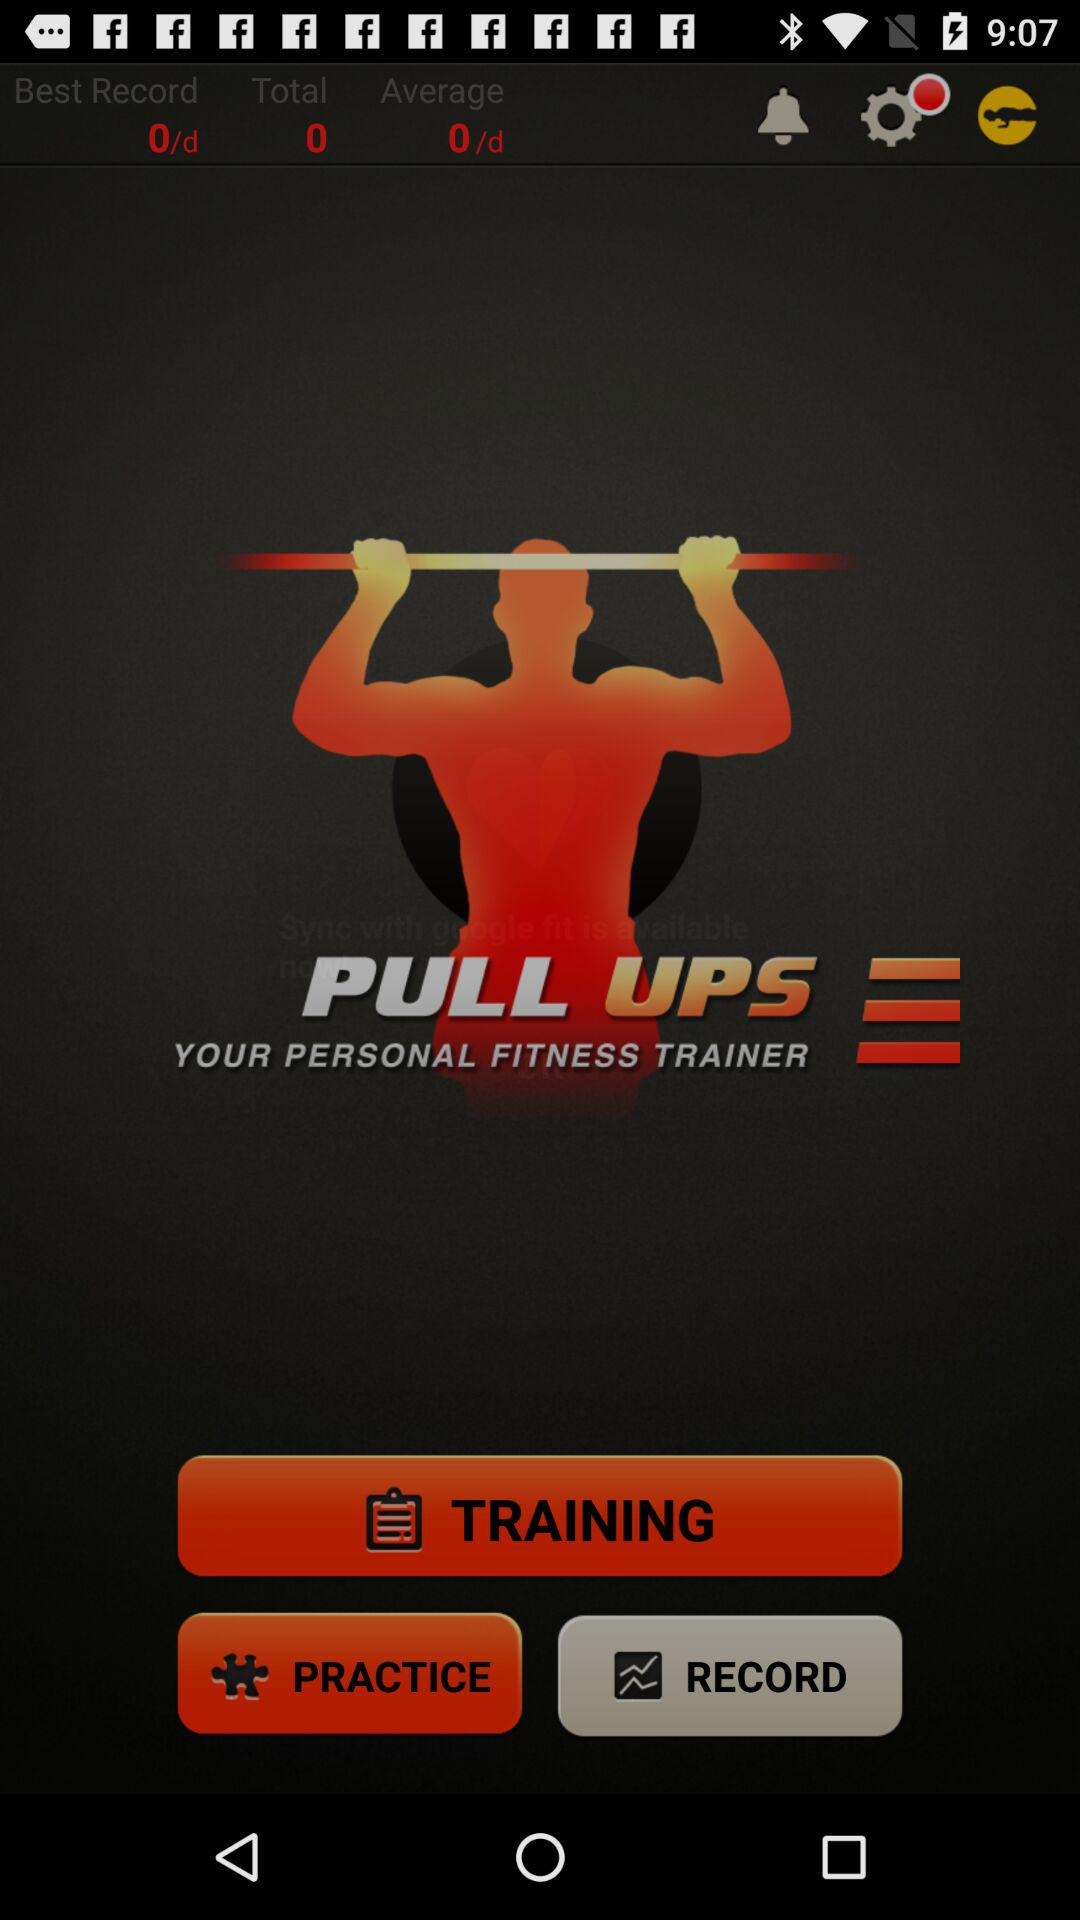What is the total record? The total record is 0. 